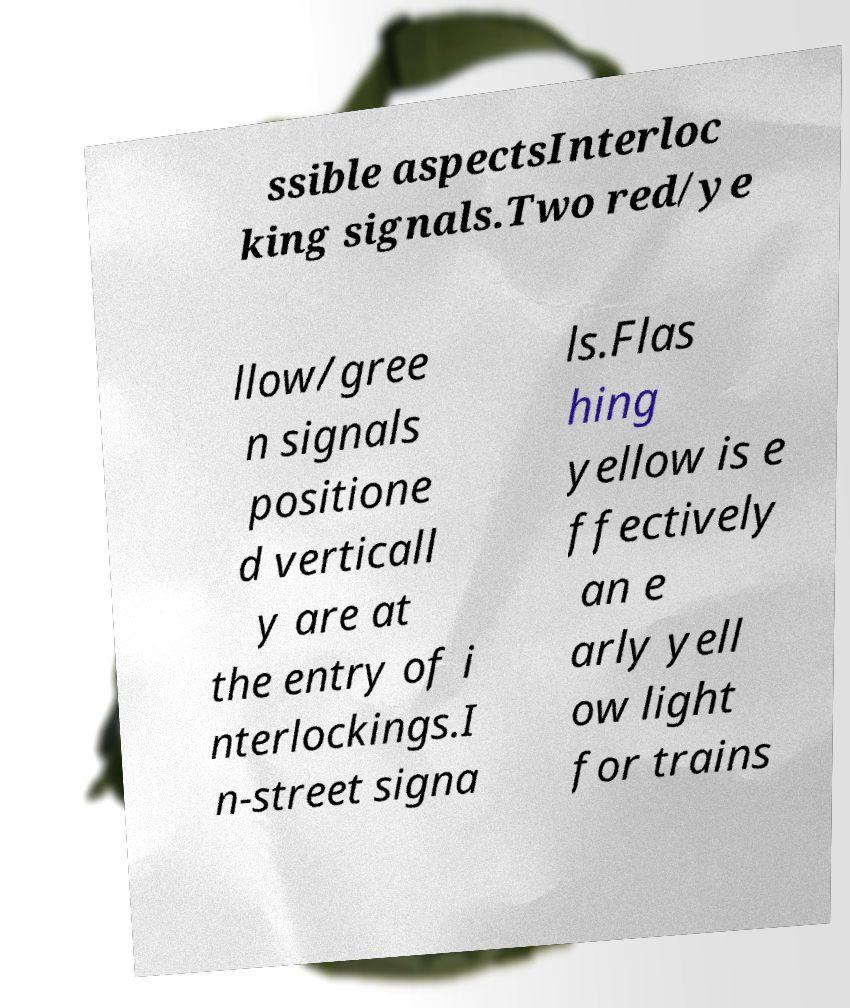Could you assist in decoding the text presented in this image and type it out clearly? ssible aspectsInterloc king signals.Two red/ye llow/gree n signals positione d verticall y are at the entry of i nterlockings.I n-street signa ls.Flas hing yellow is e ffectively an e arly yell ow light for trains 